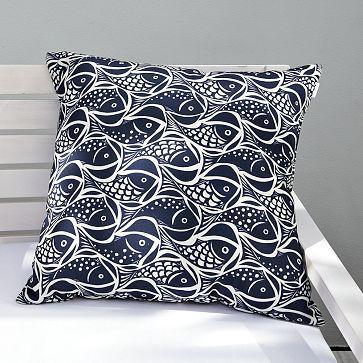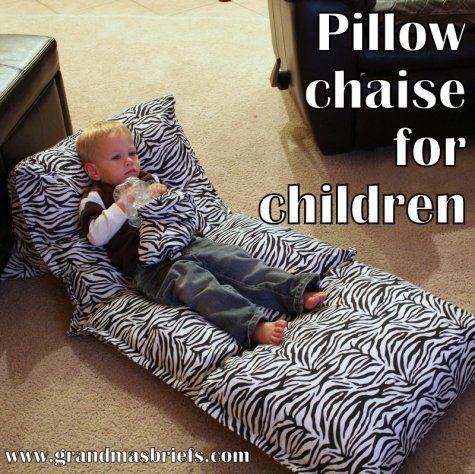The first image is the image on the left, the second image is the image on the right. Examine the images to the left and right. Is the description "The are at most 3 children present" accurate? Answer yes or no. Yes. The first image is the image on the left, the second image is the image on the right. Assess this claim about the two images: "There is a child on top of the pillow in at least one of the images.". Correct or not? Answer yes or no. Yes. 